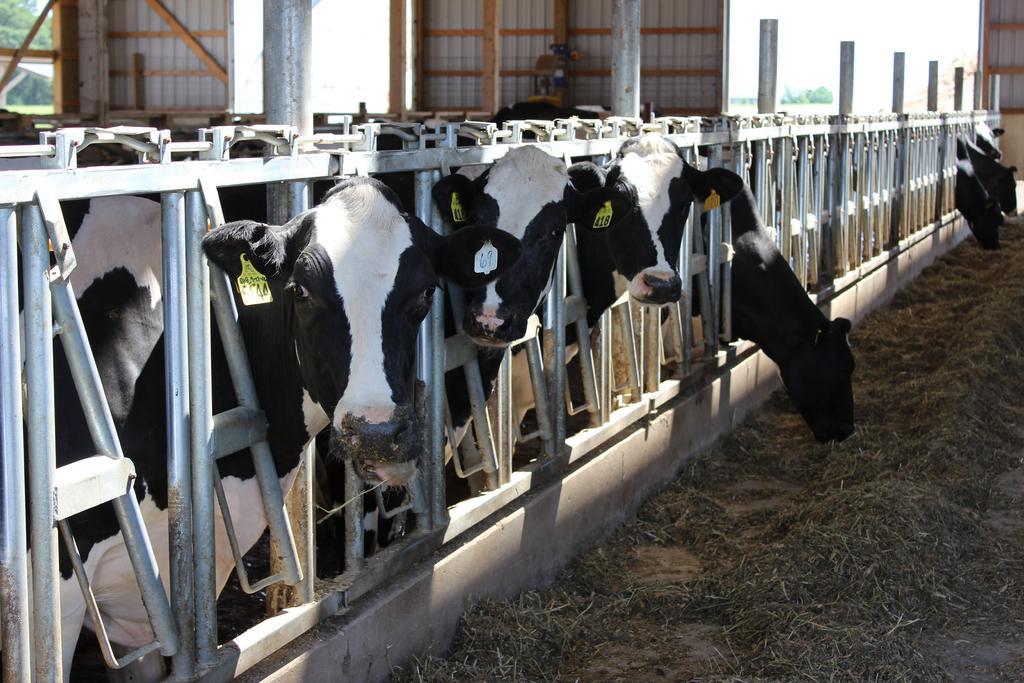How would you summarize this image in a sentence or two? In this image there are cattle in a dairy farm and there is a fencing, in front of them there is grass, in the background there are sheds. 